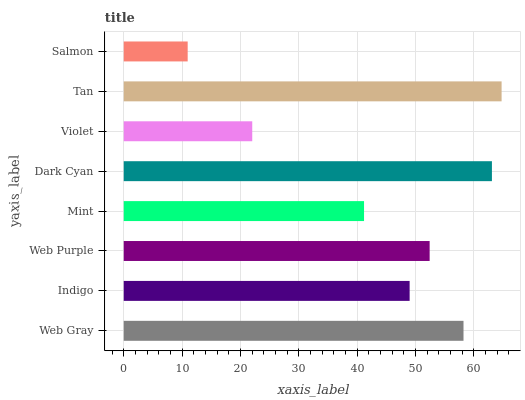Is Salmon the minimum?
Answer yes or no. Yes. Is Tan the maximum?
Answer yes or no. Yes. Is Indigo the minimum?
Answer yes or no. No. Is Indigo the maximum?
Answer yes or no. No. Is Web Gray greater than Indigo?
Answer yes or no. Yes. Is Indigo less than Web Gray?
Answer yes or no. Yes. Is Indigo greater than Web Gray?
Answer yes or no. No. Is Web Gray less than Indigo?
Answer yes or no. No. Is Web Purple the high median?
Answer yes or no. Yes. Is Indigo the low median?
Answer yes or no. Yes. Is Web Gray the high median?
Answer yes or no. No. Is Tan the low median?
Answer yes or no. No. 